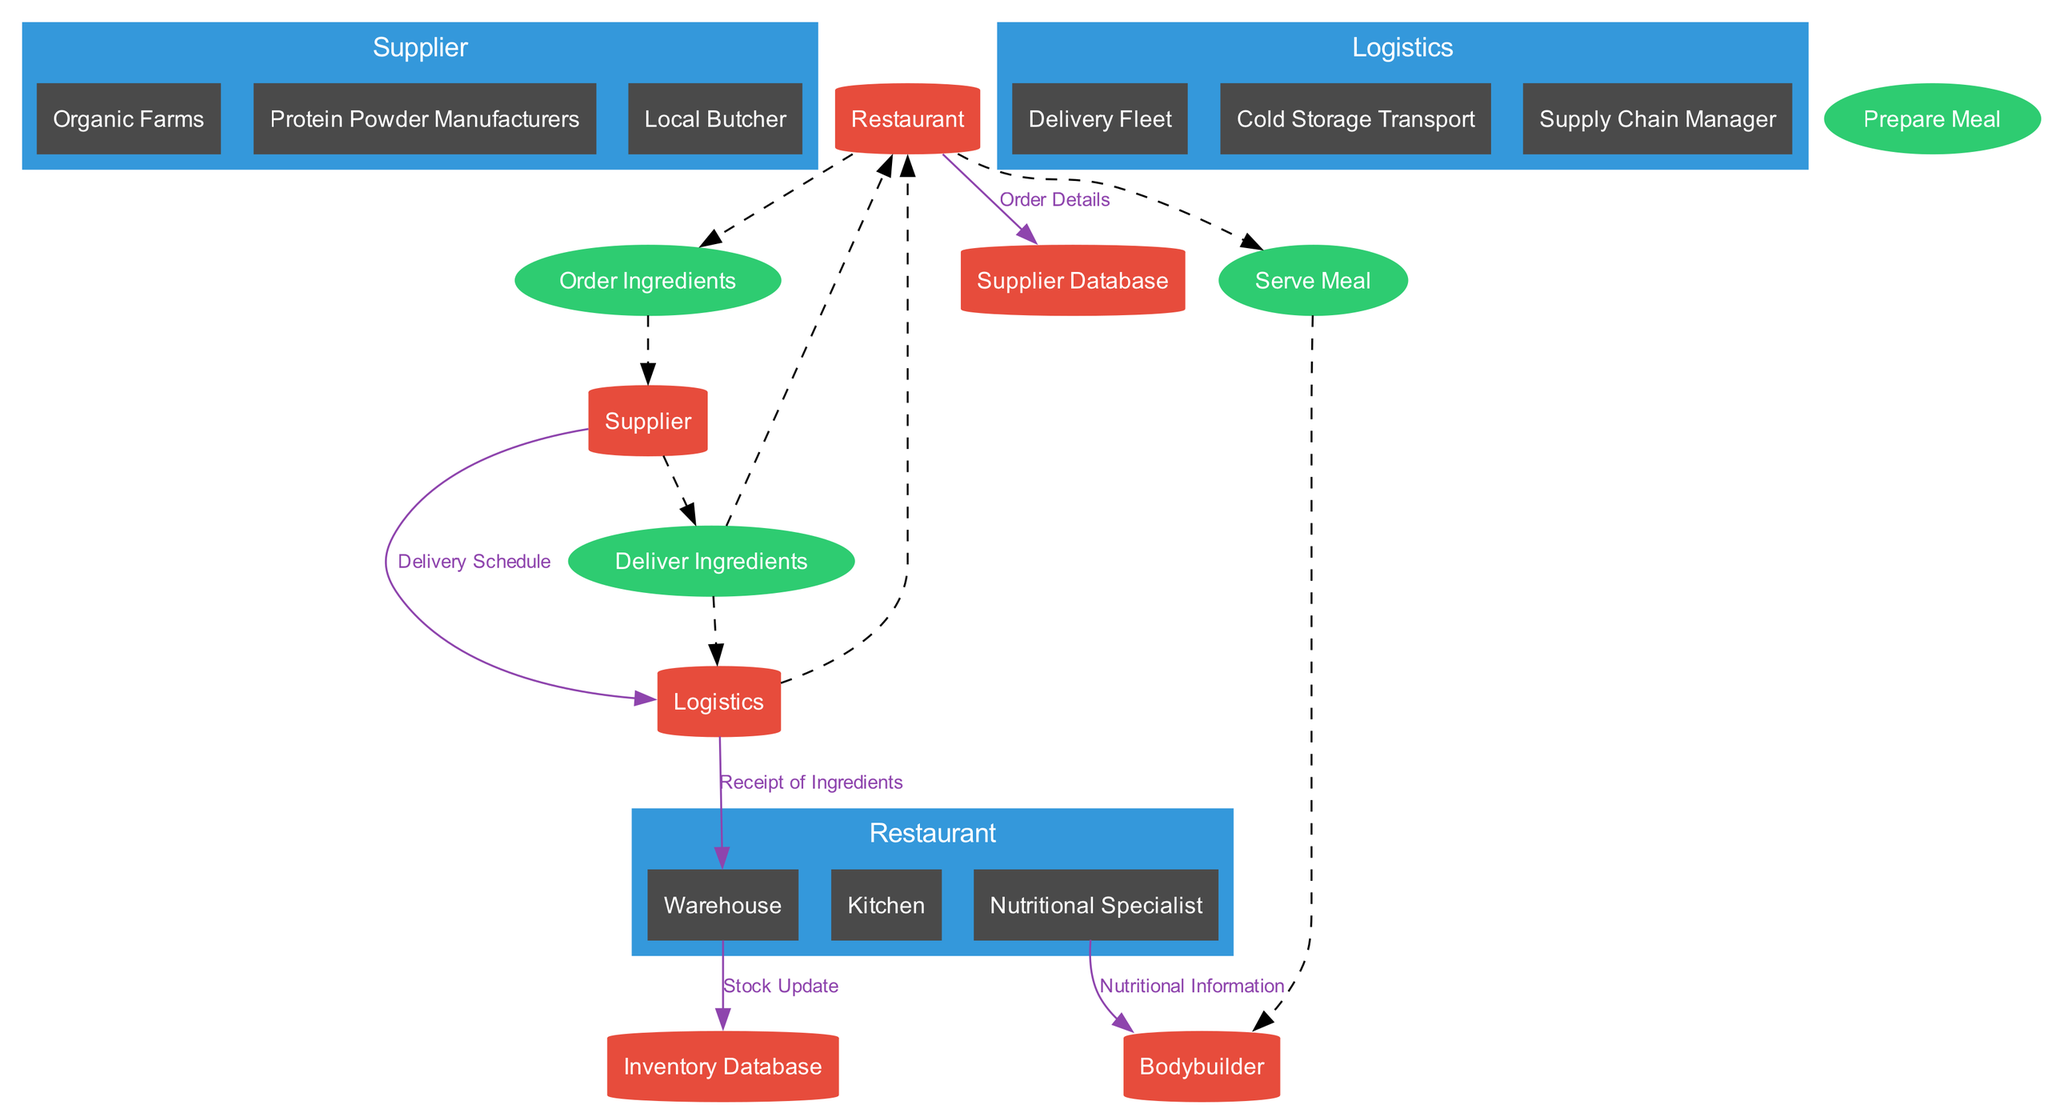What entities are listed in the diagram? The diagram includes three entities: Supplier, Restaurant, and Logistics.
Answer: Supplier, Restaurant, Logistics How many processes are shown in the diagram? There are four processes illustrated: Order Ingredients, Deliver Ingredients, Prepare Meal, and Serve Meal.
Answer: Four What is the main output from the process called "Serve Meal"? The main output is directed towards the Bodybuilder.
Answer: Bodybuilder Which entity manages the Inventory Database? The Inventory Database is managed by the Restaurant.
Answer: Restaurant What data flows from the Warehouse to the Inventory Database? The data flow between these two nodes is labeled as Stock Update.
Answer: Stock Update What is the intermediary in the "Deliver Ingredients" process? The intermediary involved in this process is Logistics.
Answer: Logistics What is the purpose of the Nutritional Specialist in the diagram? The Nutritional Specialist verifies nutritional content during the meal preparation.
Answer: Verifies nutritional content How are the "Supplier" and "Restaurant" connected in the diagram? They are connected through the "Order Ingredients" process, where the Restaurant sends orders and receives ingredients.
Answer: Order Ingredients What is the initial action taken by the Restaurant in the supply chain? The initial action is to order ingredients from the Supplier.
Answer: Order Ingredients What type of flow is the connection between "Logistics" and "Warehouse"? The flow is a "Receipt of Ingredients" data flow from Logistics to Warehouse.
Answer: Receipt of Ingredients 